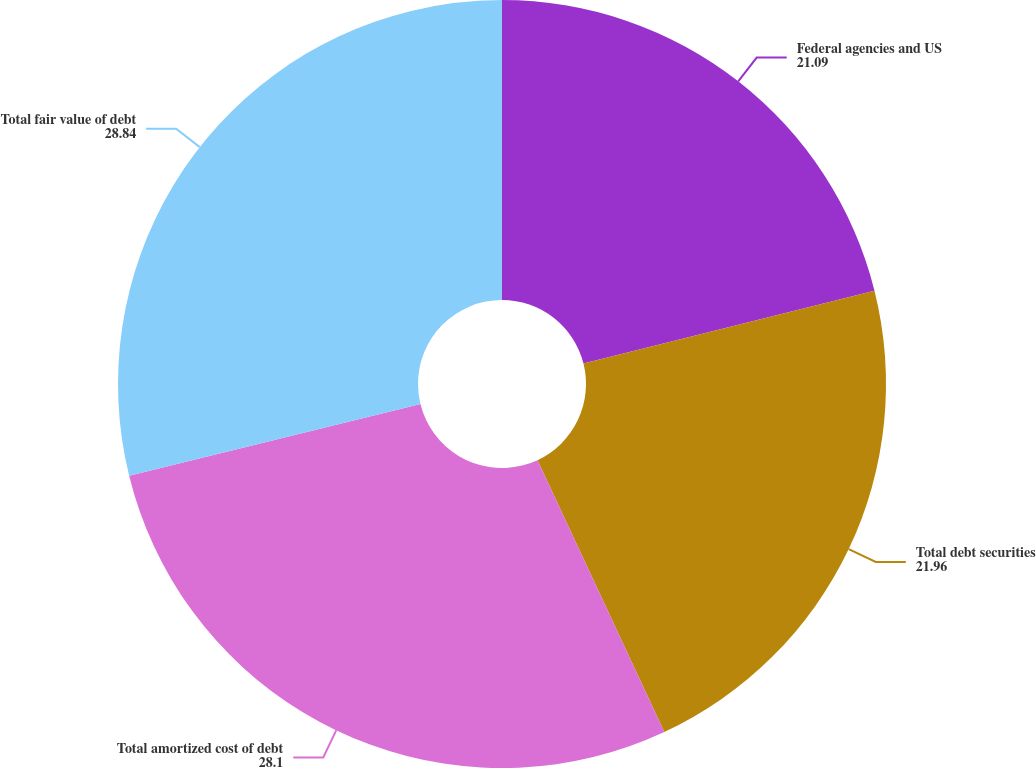Convert chart to OTSL. <chart><loc_0><loc_0><loc_500><loc_500><pie_chart><fcel>Federal agencies and US<fcel>Total debt securities<fcel>Total amortized cost of debt<fcel>Total fair value of debt<nl><fcel>21.09%<fcel>21.96%<fcel>28.1%<fcel>28.84%<nl></chart> 